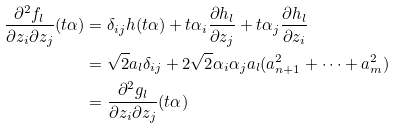Convert formula to latex. <formula><loc_0><loc_0><loc_500><loc_500>\frac { \partial ^ { 2 } f _ { l } } { \partial z _ { i } \partial z _ { j } } ( t \alpha ) & = \delta _ { i j } h ( t \alpha ) + t \alpha _ { i } \frac { \partial h _ { l } } { \partial z _ { j } } + t \alpha _ { j } \frac { \partial h _ { l } } { \partial z _ { i } } \\ & = \sqrt { 2 } a _ { l } \delta _ { i j } + 2 \sqrt { 2 } \alpha _ { i } \alpha _ { j } a _ { l } ( a ^ { 2 } _ { n + 1 } + \cdots + a ^ { 2 } _ { m } ) \\ & = \frac { \partial ^ { 2 } g _ { l } } { \partial z _ { i } \partial z _ { j } } ( t \alpha )</formula> 